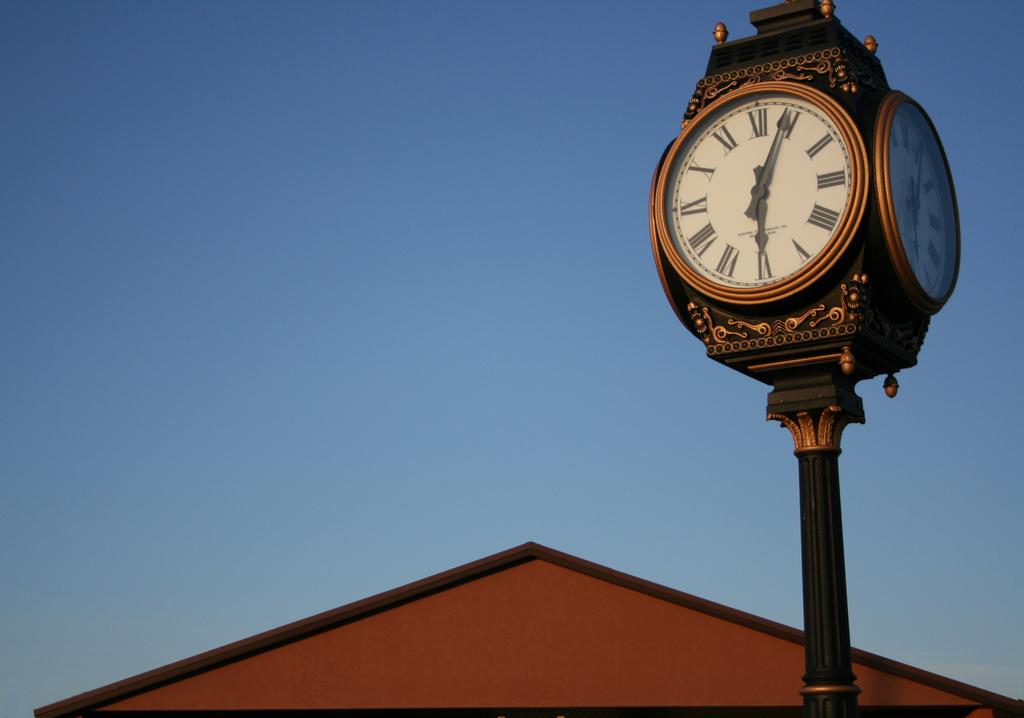What time is it?
Offer a terse response. 6:04. 